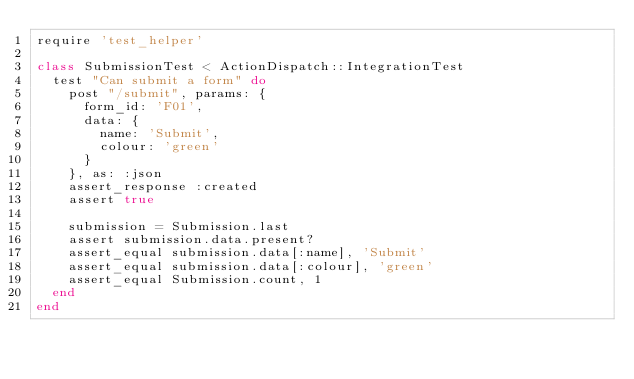<code> <loc_0><loc_0><loc_500><loc_500><_Ruby_>require 'test_helper'

class SubmissionTest < ActionDispatch::IntegrationTest
  test "Can submit a form" do
    post "/submit", params: {
      form_id: 'F01',
      data: {
        name: 'Submit',
        colour: 'green'
      }
    }, as: :json
    assert_response :created
    assert true

    submission = Submission.last
    assert submission.data.present?
    assert_equal submission.data[:name], 'Submit'
    assert_equal submission.data[:colour], 'green'
    assert_equal Submission.count, 1
  end
end
</code> 